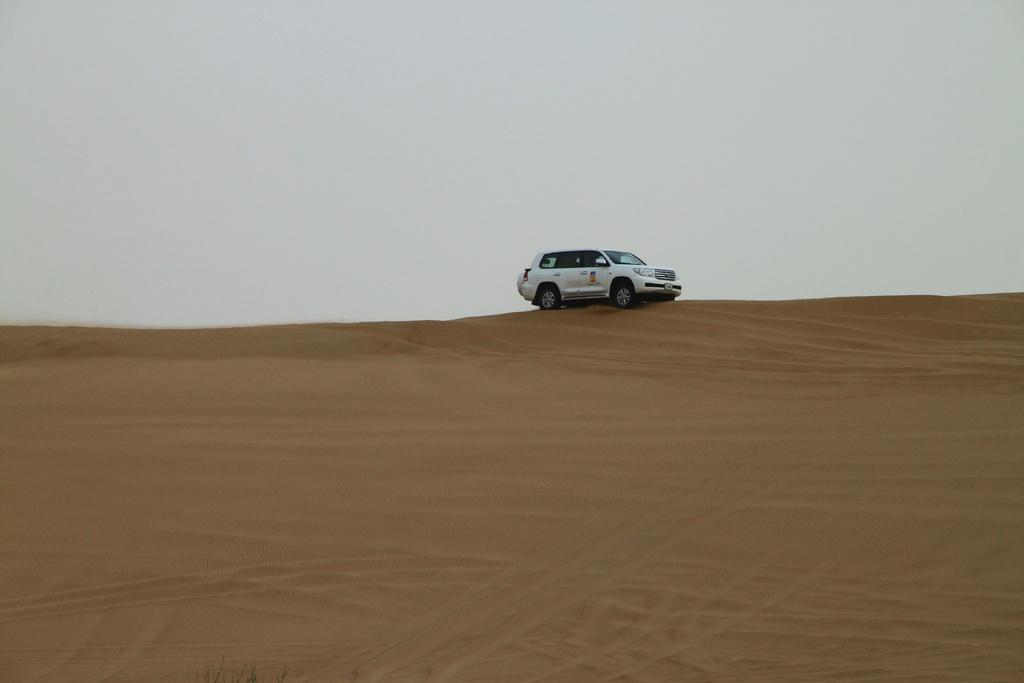What is the main subject of the image? There is a car in the image. Where is the car located? The car is on the desert. What can be seen in the background of the image? There is sky visible in the background of the image. What type of kite is being flown by the car in the image? There is no kite present in the image, and the car is not flying anything. 